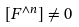Convert formula to latex. <formula><loc_0><loc_0><loc_500><loc_500>[ F ^ { \wedge n } ] \neq 0</formula> 